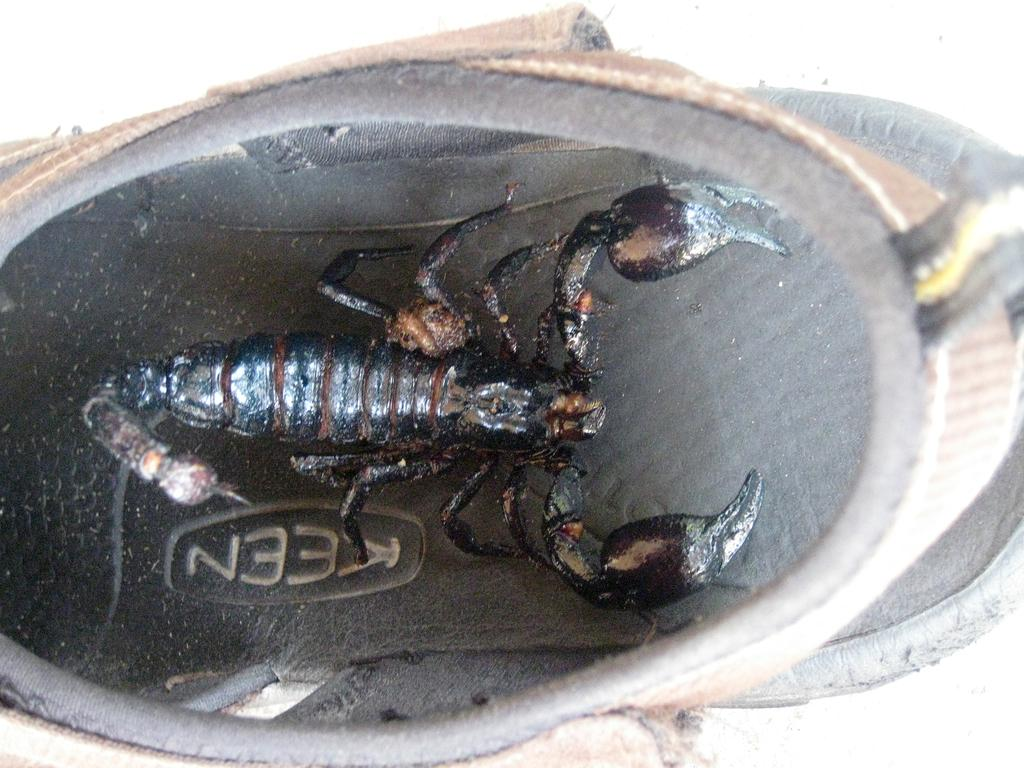<image>
Provide a brief description of the given image. OBject with a picture of a scorpion and the word KEEN on it. 